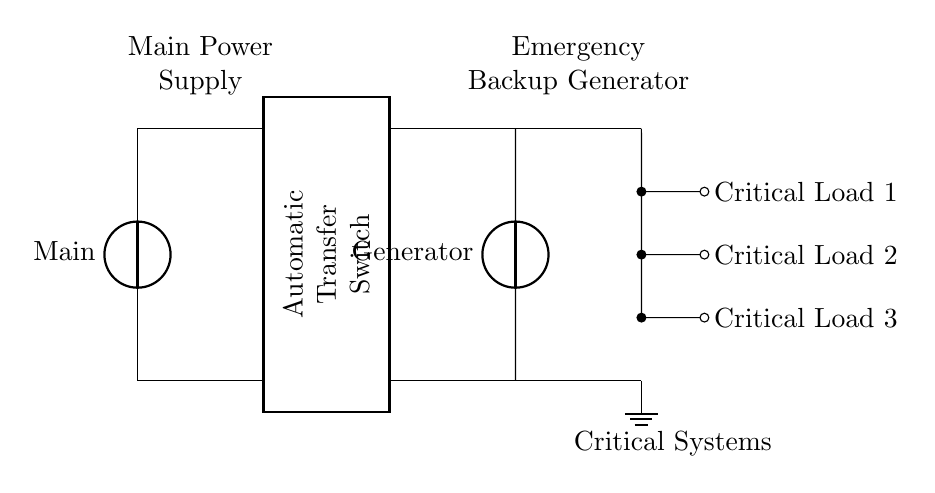What components are shown in the circuit? The components in this circuit include a main power supply, an automatic transfer switch (ATS), an emergency backup generator, and critical loads. Each component is visually represented in different sections of the circuit.
Answer: main power supply, automatic transfer switch, emergency backup generator, critical loads What is the primary function of the automatic transfer switch? The automatic transfer switch's primary function is to automatically switch the power supply from the main source to the backup generator when the main supply fails. It acts as a safety measure for critical systems.
Answer: switch power supply Which component provides power when the main supply fails? The power is provided by the emergency backup generator when the main supply fails. This ensures that critical loads continue to receive power during an outage.
Answer: emergency backup generator How many critical loads are connected to the system? There are three critical loads connected to the system, as indicated by the three branches leading off to the right from the main circuit path. Each load is separately indicated.
Answer: three What happens when the main power supply is restored? When the main power supply is restored, the automatic transfer switch reverts the power supply back to the main source, discontinuing power from the emergency generator. This transition is seamless to maintain system operation.
Answer: revert to main power supply Which component is depicted as a rectangle in the circuit? The component depicted as a rectangle is the automatic transfer switch. It is outlined and labeled in the circuit, indicating its significance in the power transition process.
Answer: automatic transfer switch 